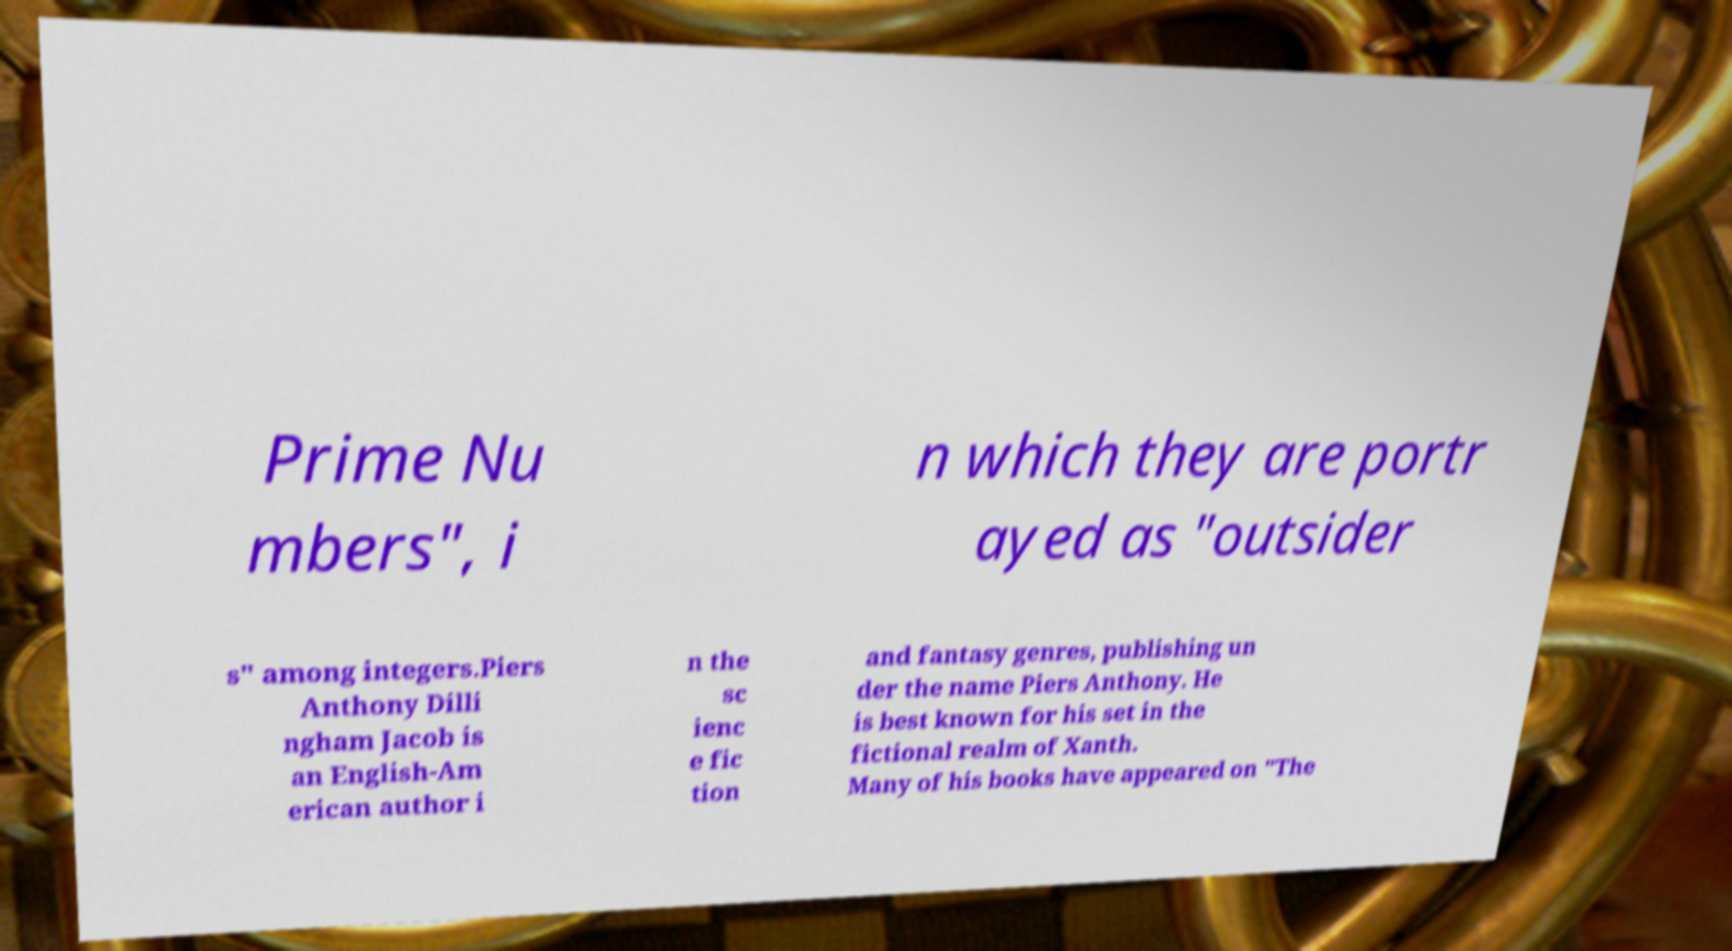What messages or text are displayed in this image? I need them in a readable, typed format. Prime Nu mbers", i n which they are portr ayed as "outsider s" among integers.Piers Anthony Dilli ngham Jacob is an English-Am erican author i n the sc ienc e fic tion and fantasy genres, publishing un der the name Piers Anthony. He is best known for his set in the fictional realm of Xanth. Many of his books have appeared on "The 